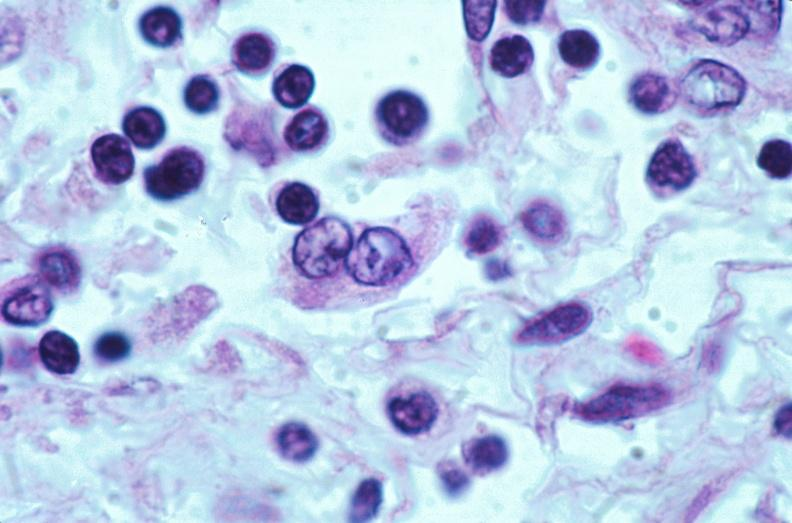does this image show lymph nodes, nodular sclerosing hodgkins disease?
Answer the question using a single word or phrase. Yes 